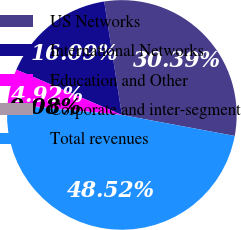<chart> <loc_0><loc_0><loc_500><loc_500><pie_chart><fcel>US Networks<fcel>International Networks<fcel>Education and Other<fcel>Corporate and inter-segment<fcel>Total revenues<nl><fcel>30.39%<fcel>16.09%<fcel>4.92%<fcel>0.08%<fcel>48.52%<nl></chart> 